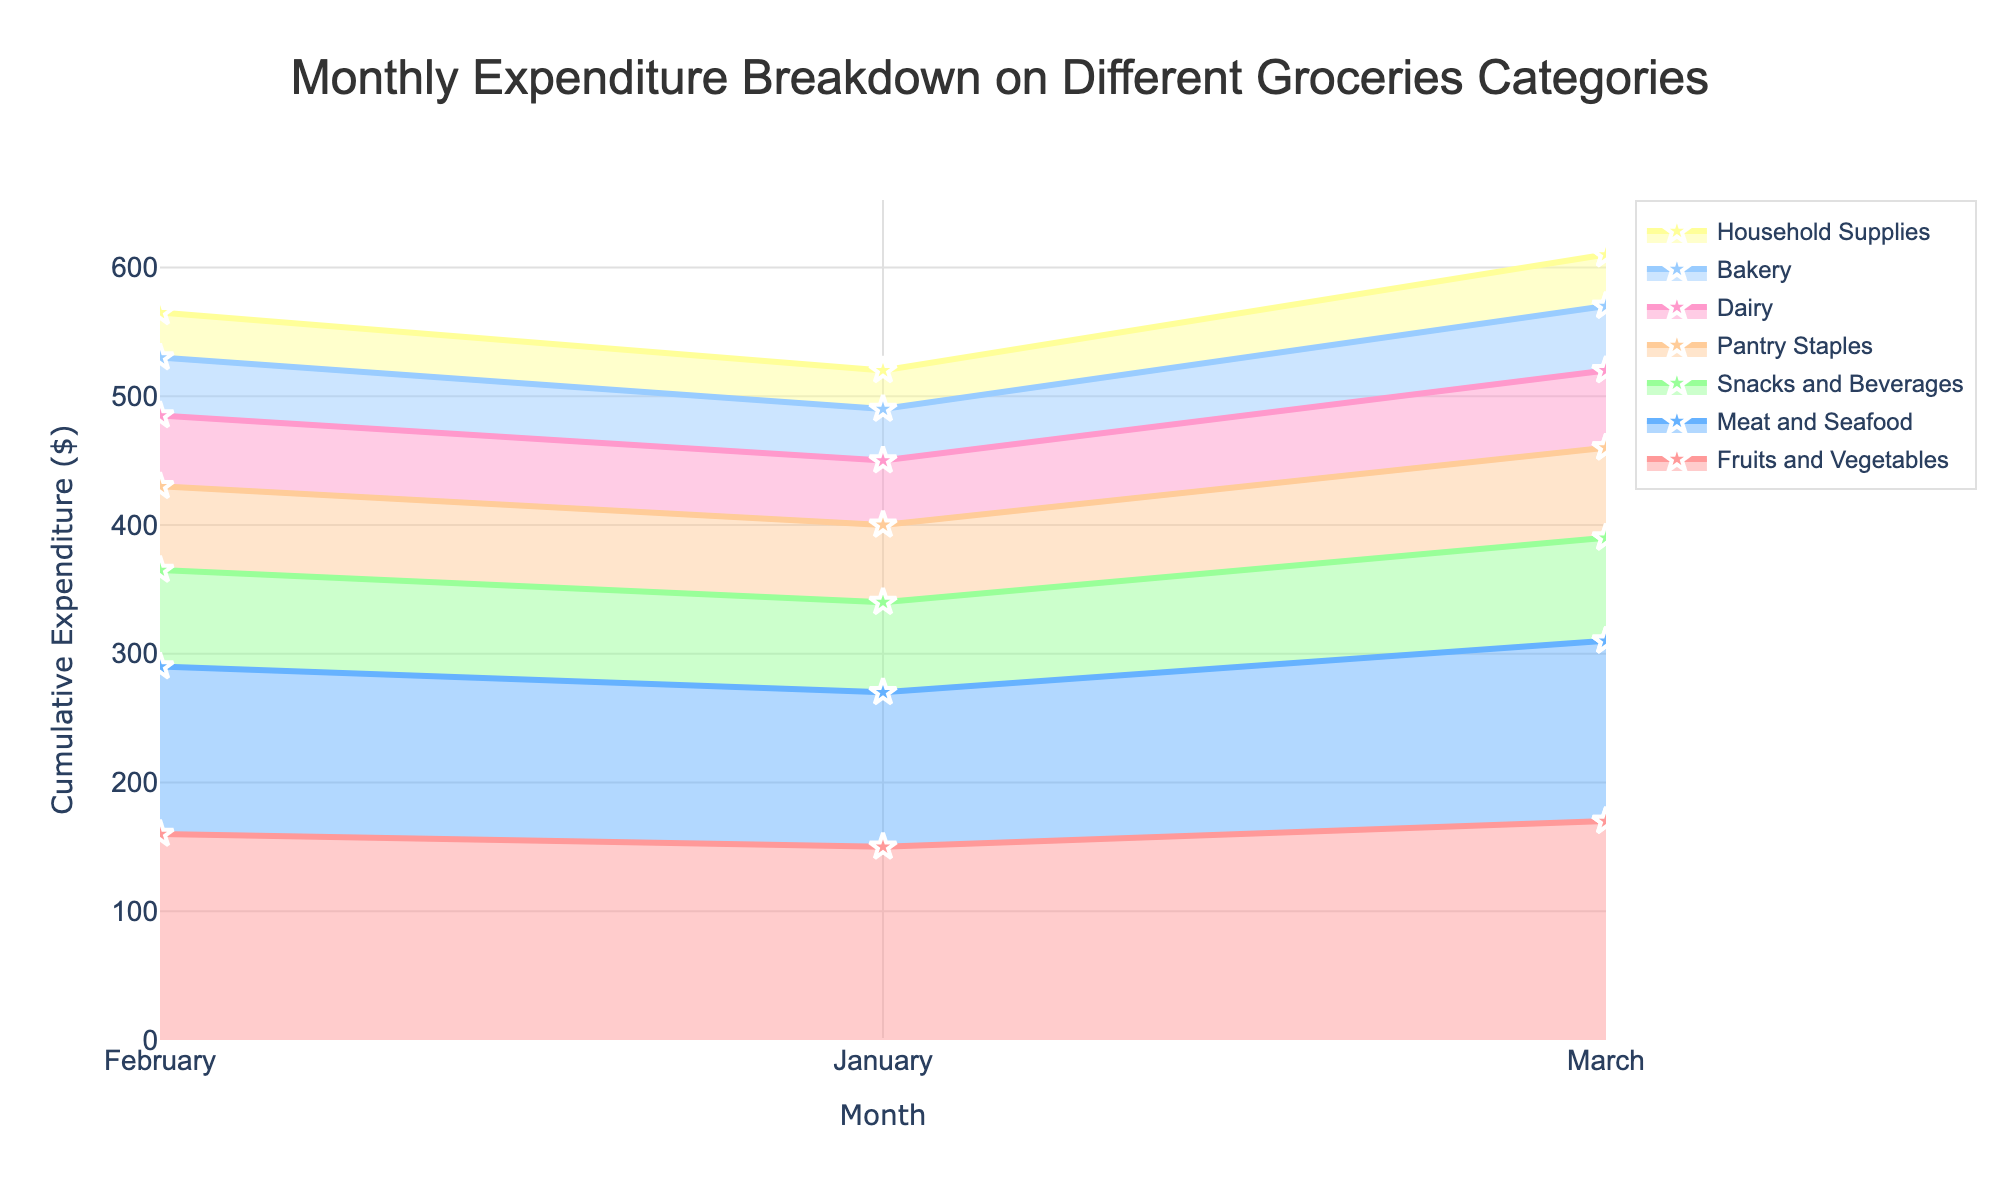What is the title of the plot? The title is displayed at the top of the plot. It summarizes the content of the figure.
Answer: Monthly Expenditure Breakdown on Different Groceries Categories Which month has the highest cumulative expenditure for Fruits and Vegetables? Assess the cumulative expenditure line for Fruits and Vegetables in each month and identify the highest point. The value increases as the months progress.
Answer: March How much did the cumulative expenditure for Dairy increase from February to March? Check the cumulative expenditure for Dairy in February and in March, then subtract the February value from the March value.
Answer: $5 Which category had the lowest expenditure in January? Look for the category with the lowest data point on the y-axis in January.
Answer: Household Supplies What is the total expenditure in February? Sum all the cumulative expenditure values for each category in February.
Answer: $560 Did the expenditure on Meat and Seafood increase consistently over the three months? Compare the expenditure for Meat and Seafood in January, February, and March by looking at the cumulative line for this category.
Answer: Yes How does the expenditure on Snacks and Beverages in March compare to February? Compare the cumulative value for Snacks and Beverages in March to February.
Answer: Higher in March Which category saw the largest increase from January to March? Calculate the difference between January and March cumulative values for each category and find the maximum value.
Answer: Fruits and Vegetables What was the cumulative expenditure on Bakery goods in March? Locate the end point of the cumulative line for Bakery in March.
Answer: $50 Was there a month where the expenditure on Pantry Staples did not increase? Examine the cumulative line for Pantry Staples across the three months to see if it increased each month.
Answer: No 